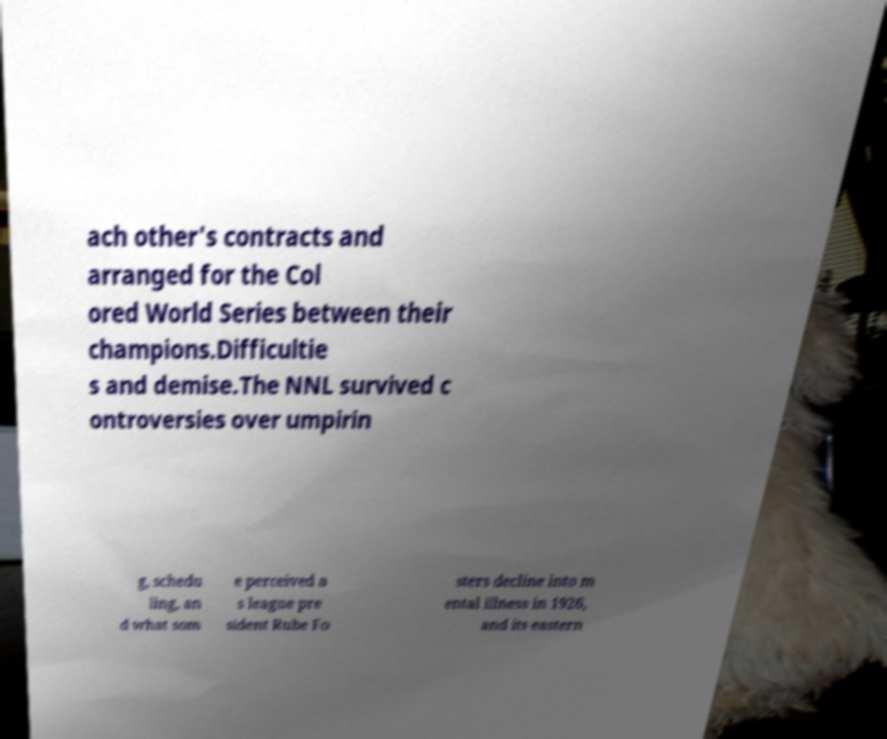Can you accurately transcribe the text from the provided image for me? ach other's contracts and arranged for the Col ored World Series between their champions.Difficultie s and demise.The NNL survived c ontroversies over umpirin g, schedu ling, an d what som e perceived a s league pre sident Rube Fo sters decline into m ental illness in 1926, and its eastern 